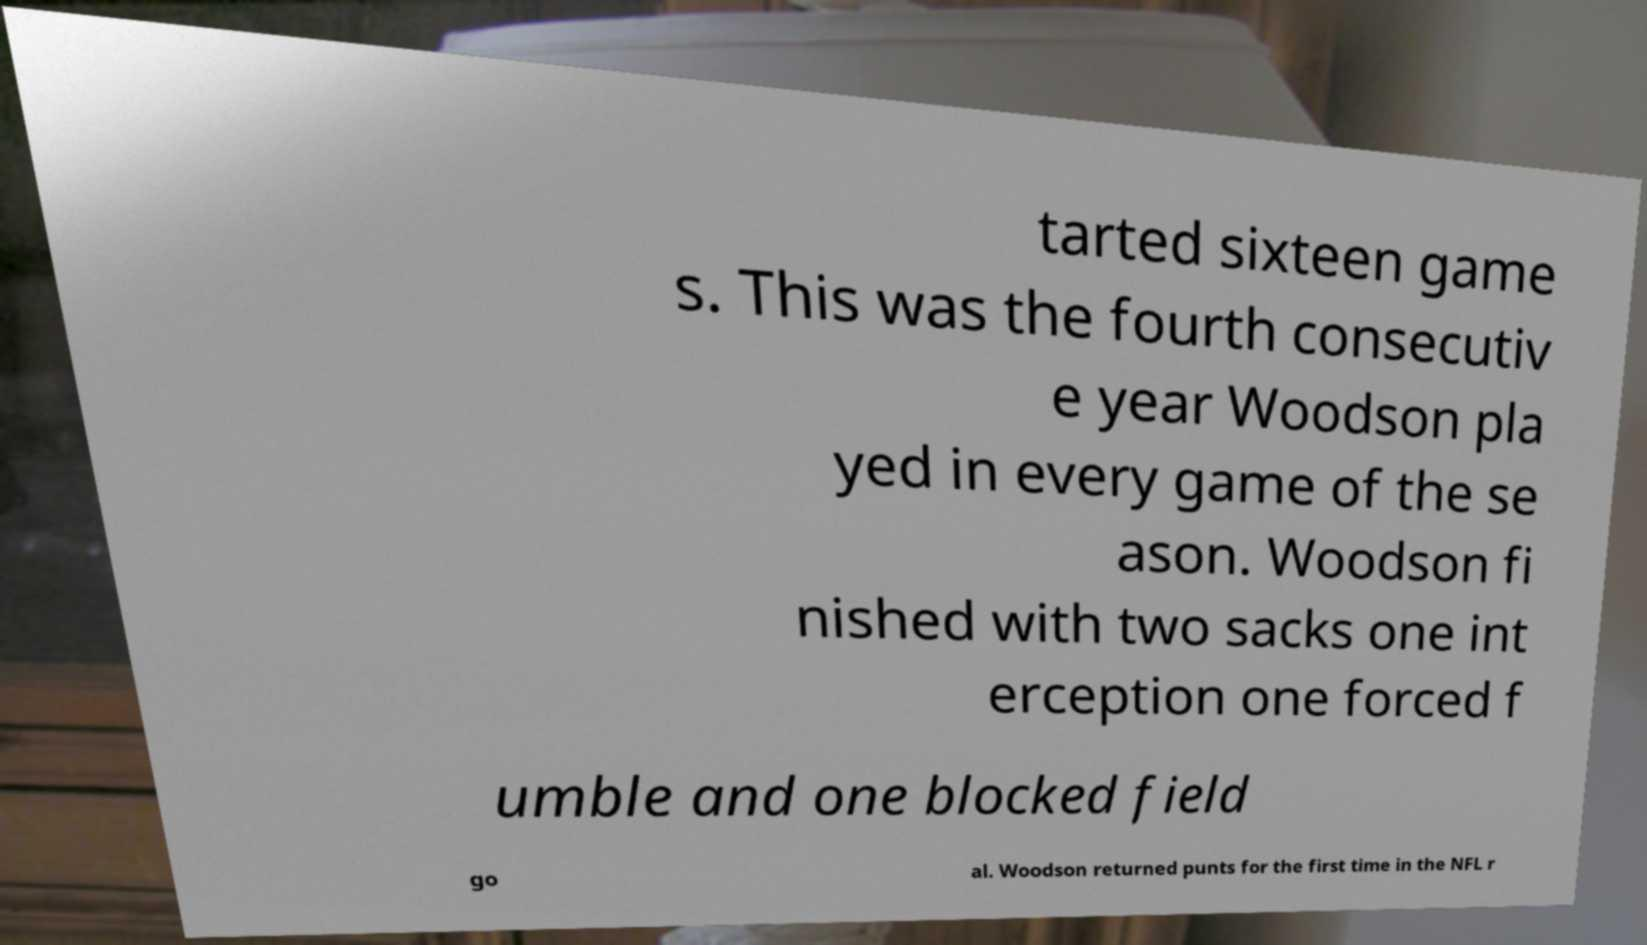There's text embedded in this image that I need extracted. Can you transcribe it verbatim? tarted sixteen game s. This was the fourth consecutiv e year Woodson pla yed in every game of the se ason. Woodson fi nished with two sacks one int erception one forced f umble and one blocked field go al. Woodson returned punts for the first time in the NFL r 